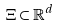Convert formula to latex. <formula><loc_0><loc_0><loc_500><loc_500>\Xi \subset \mathbb { R } ^ { d }</formula> 